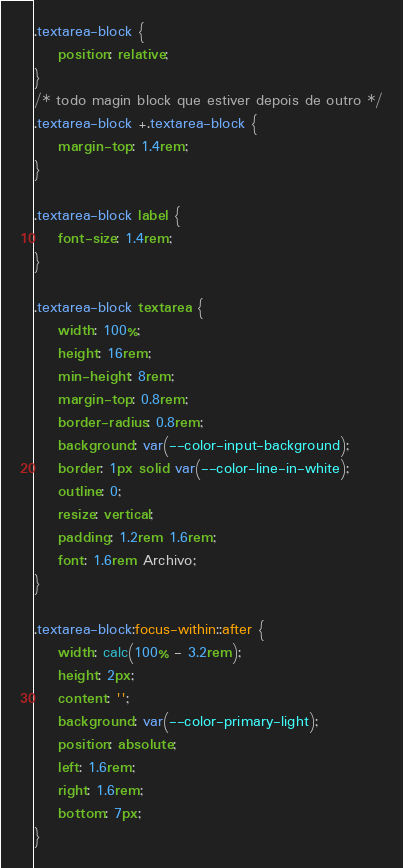<code> <loc_0><loc_0><loc_500><loc_500><_CSS_>.textarea-block {
    position: relative;
}
/* todo magin block que estiver depois de outro */
.textarea-block +.textarea-block { 
    margin-top: 1.4rem;
}

.textarea-block label {
    font-size: 1.4rem;
}

.textarea-block textarea {
    width: 100%;
    height: 16rem;
    min-height: 8rem;
    margin-top: 0.8rem;
    border-radius: 0.8rem;
    background: var(--color-input-background);
    border: 1px solid var(--color-line-in-white);
    outline: 0;
    resize: vertical;
    padding: 1.2rem 1.6rem;
    font: 1.6rem Archivo;
}

.textarea-block:focus-within::after {
    width: calc(100% - 3.2rem);
    height: 2px;
    content: '';
    background: var(--color-primary-light);
    position: absolute;
    left: 1.6rem;
    right: 1.6rem;
    bottom: 7px;
}</code> 